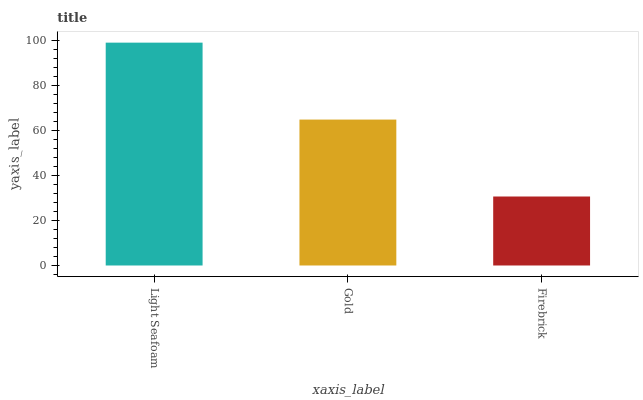Is Firebrick the minimum?
Answer yes or no. Yes. Is Light Seafoam the maximum?
Answer yes or no. Yes. Is Gold the minimum?
Answer yes or no. No. Is Gold the maximum?
Answer yes or no. No. Is Light Seafoam greater than Gold?
Answer yes or no. Yes. Is Gold less than Light Seafoam?
Answer yes or no. Yes. Is Gold greater than Light Seafoam?
Answer yes or no. No. Is Light Seafoam less than Gold?
Answer yes or no. No. Is Gold the high median?
Answer yes or no. Yes. Is Gold the low median?
Answer yes or no. Yes. Is Firebrick the high median?
Answer yes or no. No. Is Light Seafoam the low median?
Answer yes or no. No. 